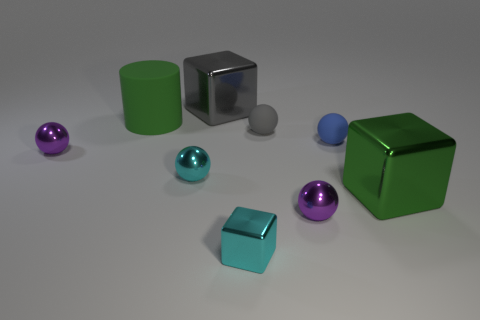What shape is the big shiny thing that is the same color as the large cylinder?
Make the answer very short. Cube. Is there another small matte object that has the same shape as the gray rubber object?
Provide a succinct answer. Yes. There is another metal cube that is the same size as the gray metal cube; what color is it?
Make the answer very short. Green. There is a tiny rubber thing that is behind the matte thing that is in front of the gray rubber thing; what color is it?
Make the answer very short. Gray. Is the color of the metal block that is to the right of the tiny cyan block the same as the big matte cylinder?
Your response must be concise. Yes. There is a shiny thing in front of the metal ball that is to the right of the large cube behind the blue rubber sphere; what shape is it?
Offer a very short reply. Cube. What number of big green shiny objects are behind the large green thing left of the small gray thing?
Offer a very short reply. 0. Is the cyan block made of the same material as the gray block?
Keep it short and to the point. Yes. There is a metallic ball that is on the right side of the tiny rubber object that is behind the tiny blue ball; how many tiny purple shiny spheres are on the right side of it?
Your answer should be very brief. 0. What is the color of the large shiny cube that is right of the small metallic block?
Offer a very short reply. Green. 